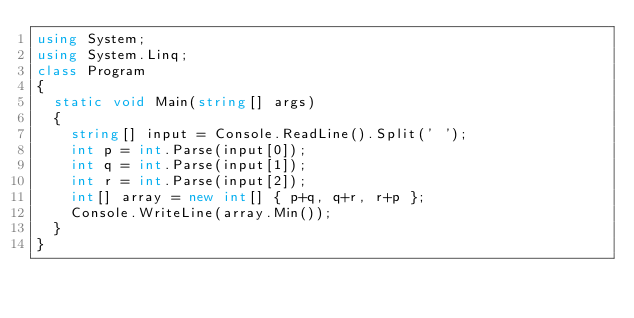<code> <loc_0><loc_0><loc_500><loc_500><_C#_>using System;
using System.Linq;
class Program
{
  static void Main(string[] args)
  {
    string[] input = Console.ReadLine().Split(' ');
    int p = int.Parse(input[0]);
    int q = int.Parse(input[1]);
    int r = int.Parse(input[2]);
    int[] array = new int[] { p+q, q+r, r+p };
    Console.WriteLine(array.Min());
  }
}
</code> 